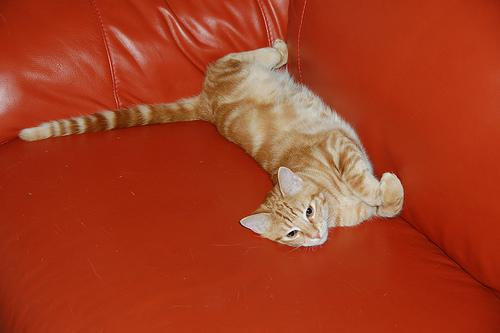Question: what animal is in the picture?
Choices:
A. Mouse.
B. A cat.
C. Dog.
D. Snake.
Answer with the letter. Answer: B Question: what color is the couch?
Choices:
A. Brown.
B. Black.
C. Red.
D. Dark orange.
Answer with the letter. Answer: D Question: how is the cat positioned?
Choices:
A. Standing.
B. On it's side.
C. On two legs.
D. Running.
Answer with the letter. Answer: B Question: who is laying on the couch?
Choices:
A. A dog.
B. A Raccoon.
C. A Rabbit.
D. The cat.
Answer with the letter. Answer: D 